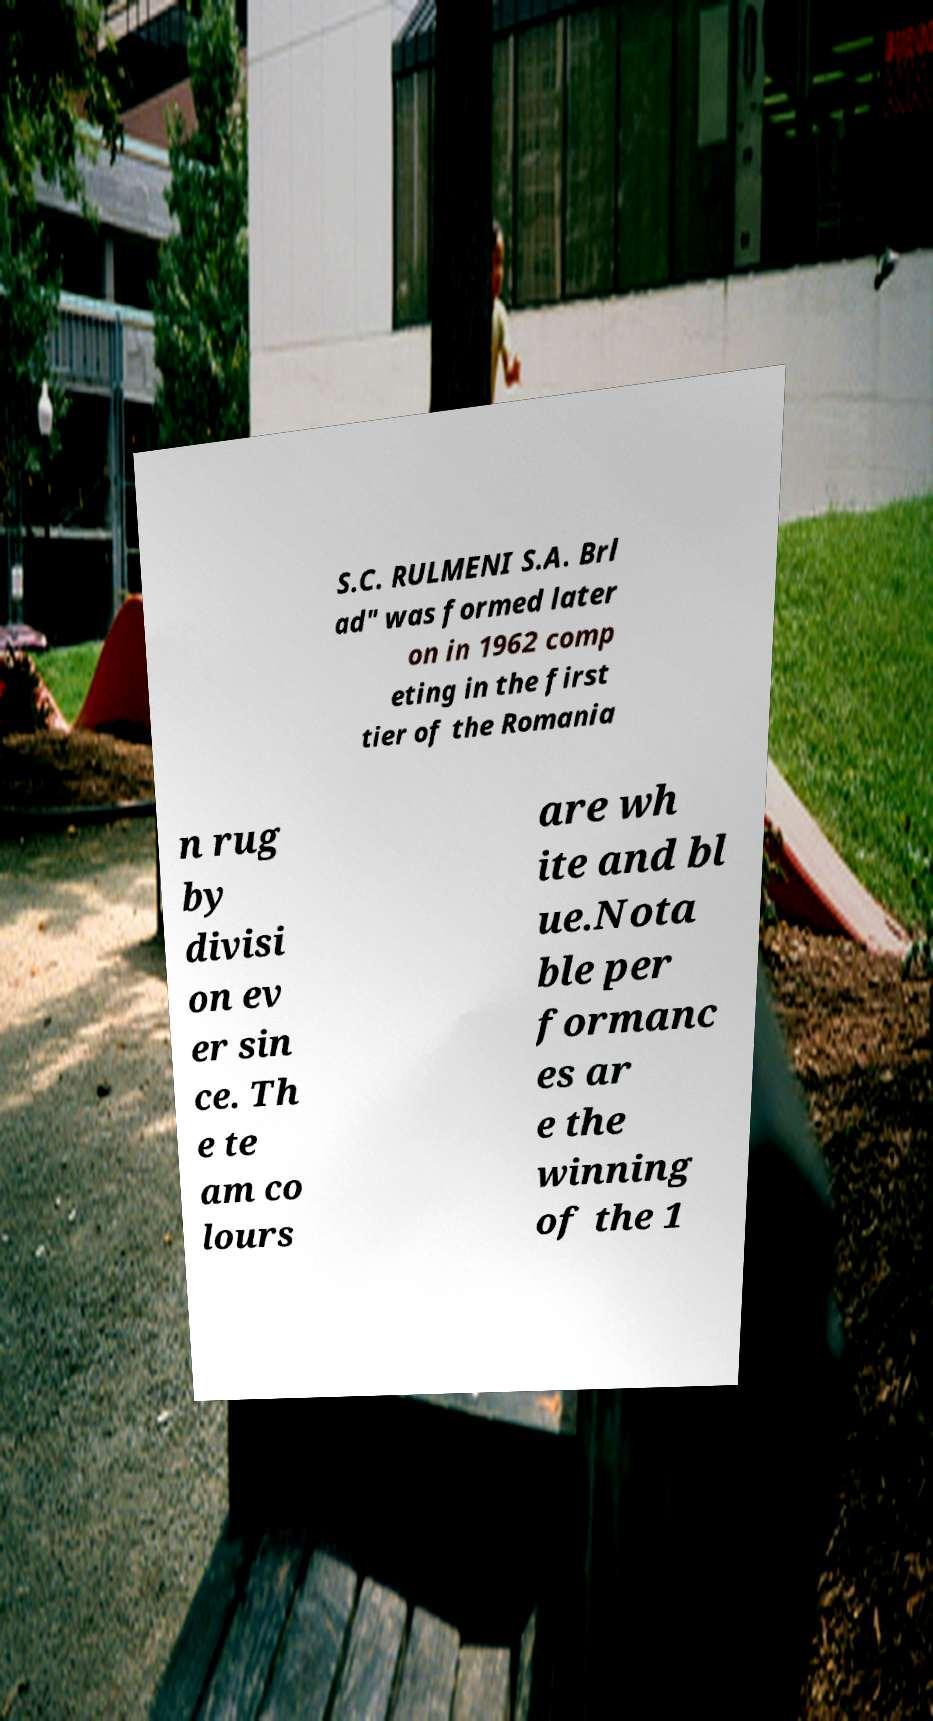What messages or text are displayed in this image? I need them in a readable, typed format. S.C. RULMENI S.A. Brl ad" was formed later on in 1962 comp eting in the first tier of the Romania n rug by divisi on ev er sin ce. Th e te am co lours are wh ite and bl ue.Nota ble per formanc es ar e the winning of the 1 